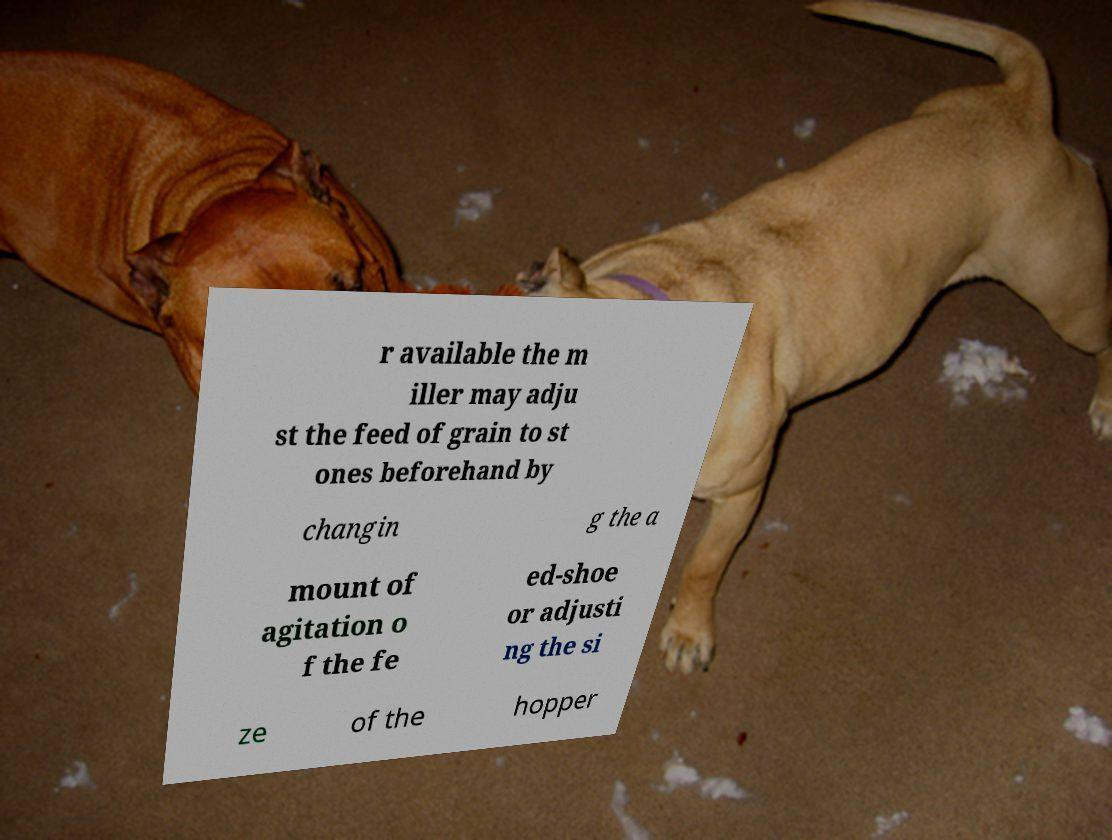Could you assist in decoding the text presented in this image and type it out clearly? r available the m iller may adju st the feed of grain to st ones beforehand by changin g the a mount of agitation o f the fe ed-shoe or adjusti ng the si ze of the hopper 